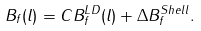Convert formula to latex. <formula><loc_0><loc_0><loc_500><loc_500>B _ { f } ( l ) = C B _ { f } ^ { L D } ( l ) + \Delta B _ { f } ^ { S h e l l } .</formula> 